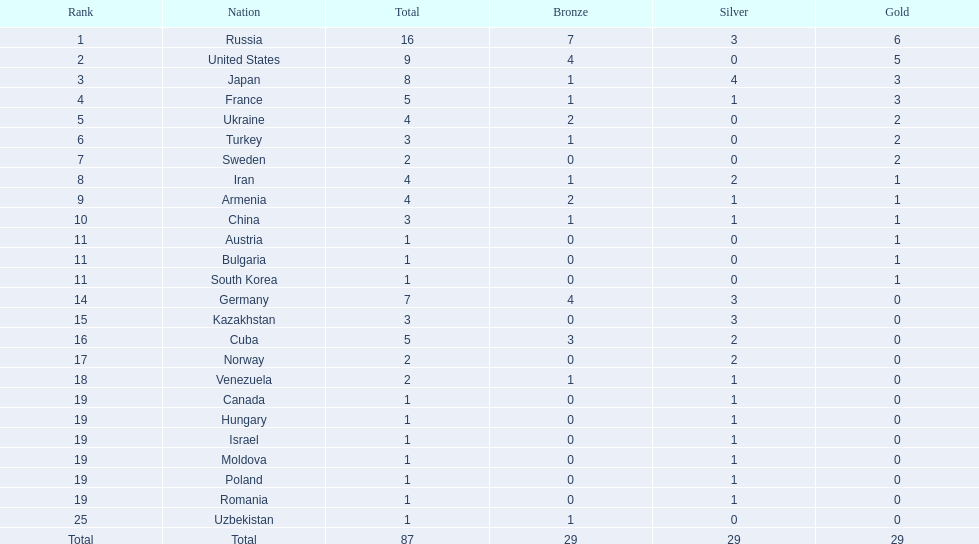Where did iran rank? 8. Where did germany rank? 14. Which of those did make it into the top 10 rank? Germany. 